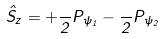<formula> <loc_0><loc_0><loc_500><loc_500>\hat { S } _ { z } = + \frac { } 2 P _ { \psi _ { 1 } } - \frac { } 2 P _ { \psi _ { 2 } }</formula> 